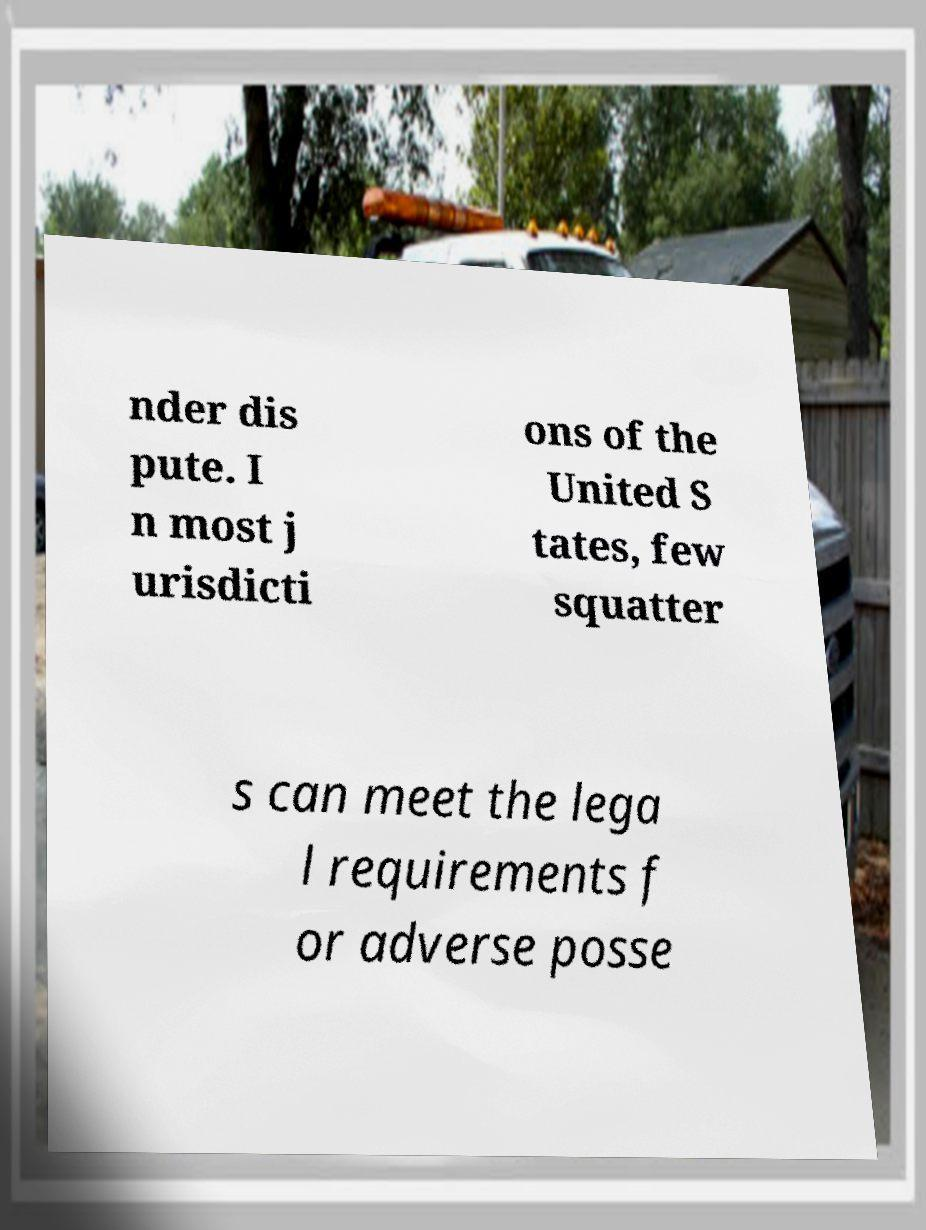I need the written content from this picture converted into text. Can you do that? nder dis pute. I n most j urisdicti ons of the United S tates, few squatter s can meet the lega l requirements f or adverse posse 